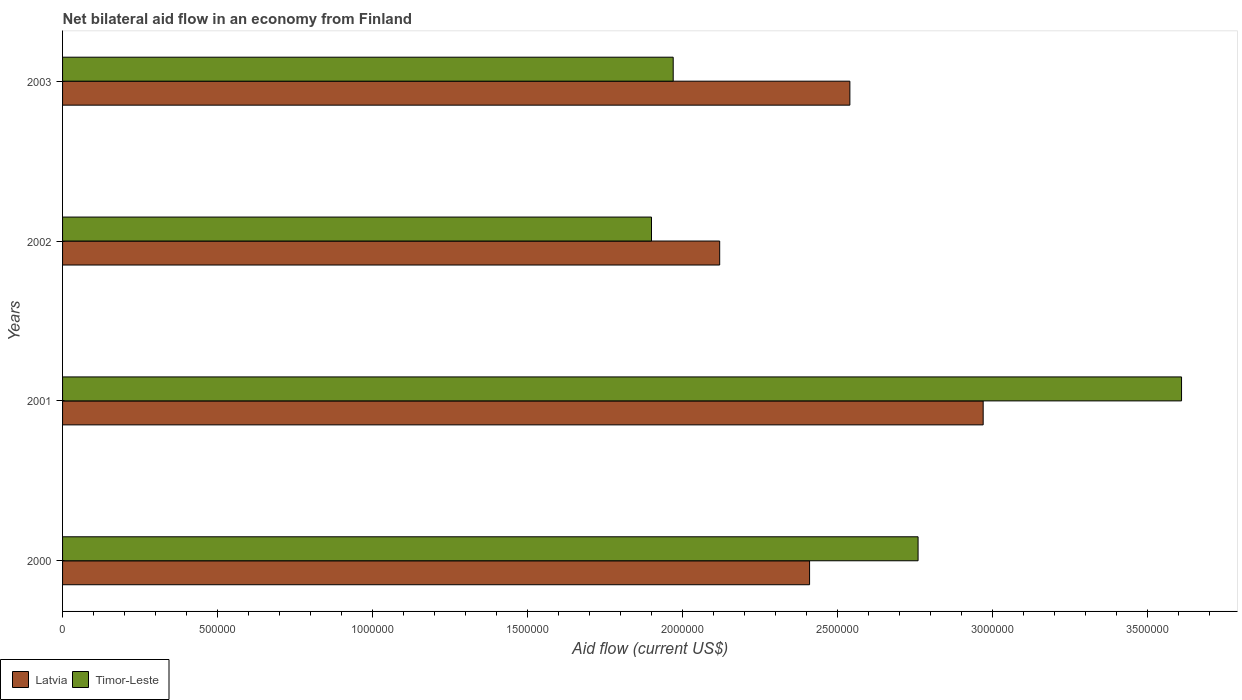How many groups of bars are there?
Ensure brevity in your answer.  4. Are the number of bars per tick equal to the number of legend labels?
Offer a terse response. Yes. What is the label of the 4th group of bars from the top?
Make the answer very short. 2000. What is the net bilateral aid flow in Latvia in 2000?
Your response must be concise. 2.41e+06. Across all years, what is the maximum net bilateral aid flow in Latvia?
Offer a terse response. 2.97e+06. Across all years, what is the minimum net bilateral aid flow in Latvia?
Offer a very short reply. 2.12e+06. In which year was the net bilateral aid flow in Timor-Leste maximum?
Make the answer very short. 2001. What is the total net bilateral aid flow in Latvia in the graph?
Ensure brevity in your answer.  1.00e+07. What is the difference between the net bilateral aid flow in Timor-Leste in 2000 and the net bilateral aid flow in Latvia in 2002?
Offer a terse response. 6.40e+05. What is the average net bilateral aid flow in Latvia per year?
Provide a succinct answer. 2.51e+06. In the year 2002, what is the difference between the net bilateral aid flow in Latvia and net bilateral aid flow in Timor-Leste?
Offer a very short reply. 2.20e+05. What is the ratio of the net bilateral aid flow in Latvia in 2000 to that in 2002?
Give a very brief answer. 1.14. What is the difference between the highest and the second highest net bilateral aid flow in Latvia?
Give a very brief answer. 4.30e+05. What is the difference between the highest and the lowest net bilateral aid flow in Latvia?
Give a very brief answer. 8.50e+05. What does the 1st bar from the top in 2000 represents?
Keep it short and to the point. Timor-Leste. What does the 1st bar from the bottom in 2002 represents?
Your answer should be compact. Latvia. How many bars are there?
Keep it short and to the point. 8. Are all the bars in the graph horizontal?
Offer a very short reply. Yes. How many years are there in the graph?
Your answer should be very brief. 4. What is the difference between two consecutive major ticks on the X-axis?
Provide a succinct answer. 5.00e+05. Where does the legend appear in the graph?
Give a very brief answer. Bottom left. How many legend labels are there?
Make the answer very short. 2. How are the legend labels stacked?
Ensure brevity in your answer.  Horizontal. What is the title of the graph?
Provide a short and direct response. Net bilateral aid flow in an economy from Finland. Does "Spain" appear as one of the legend labels in the graph?
Provide a short and direct response. No. What is the Aid flow (current US$) in Latvia in 2000?
Ensure brevity in your answer.  2.41e+06. What is the Aid flow (current US$) in Timor-Leste in 2000?
Keep it short and to the point. 2.76e+06. What is the Aid flow (current US$) of Latvia in 2001?
Offer a terse response. 2.97e+06. What is the Aid flow (current US$) of Timor-Leste in 2001?
Keep it short and to the point. 3.61e+06. What is the Aid flow (current US$) in Latvia in 2002?
Offer a terse response. 2.12e+06. What is the Aid flow (current US$) of Timor-Leste in 2002?
Ensure brevity in your answer.  1.90e+06. What is the Aid flow (current US$) of Latvia in 2003?
Your answer should be very brief. 2.54e+06. What is the Aid flow (current US$) in Timor-Leste in 2003?
Ensure brevity in your answer.  1.97e+06. Across all years, what is the maximum Aid flow (current US$) of Latvia?
Offer a terse response. 2.97e+06. Across all years, what is the maximum Aid flow (current US$) in Timor-Leste?
Offer a terse response. 3.61e+06. Across all years, what is the minimum Aid flow (current US$) in Latvia?
Provide a short and direct response. 2.12e+06. Across all years, what is the minimum Aid flow (current US$) in Timor-Leste?
Keep it short and to the point. 1.90e+06. What is the total Aid flow (current US$) in Latvia in the graph?
Your answer should be very brief. 1.00e+07. What is the total Aid flow (current US$) in Timor-Leste in the graph?
Your response must be concise. 1.02e+07. What is the difference between the Aid flow (current US$) of Latvia in 2000 and that in 2001?
Ensure brevity in your answer.  -5.60e+05. What is the difference between the Aid flow (current US$) in Timor-Leste in 2000 and that in 2001?
Provide a short and direct response. -8.50e+05. What is the difference between the Aid flow (current US$) in Latvia in 2000 and that in 2002?
Your response must be concise. 2.90e+05. What is the difference between the Aid flow (current US$) of Timor-Leste in 2000 and that in 2002?
Provide a short and direct response. 8.60e+05. What is the difference between the Aid flow (current US$) in Timor-Leste in 2000 and that in 2003?
Provide a succinct answer. 7.90e+05. What is the difference between the Aid flow (current US$) of Latvia in 2001 and that in 2002?
Offer a terse response. 8.50e+05. What is the difference between the Aid flow (current US$) in Timor-Leste in 2001 and that in 2002?
Your response must be concise. 1.71e+06. What is the difference between the Aid flow (current US$) of Timor-Leste in 2001 and that in 2003?
Keep it short and to the point. 1.64e+06. What is the difference between the Aid flow (current US$) in Latvia in 2002 and that in 2003?
Offer a terse response. -4.20e+05. What is the difference between the Aid flow (current US$) in Latvia in 2000 and the Aid flow (current US$) in Timor-Leste in 2001?
Make the answer very short. -1.20e+06. What is the difference between the Aid flow (current US$) in Latvia in 2000 and the Aid flow (current US$) in Timor-Leste in 2002?
Your response must be concise. 5.10e+05. What is the difference between the Aid flow (current US$) in Latvia in 2001 and the Aid flow (current US$) in Timor-Leste in 2002?
Make the answer very short. 1.07e+06. What is the average Aid flow (current US$) of Latvia per year?
Make the answer very short. 2.51e+06. What is the average Aid flow (current US$) in Timor-Leste per year?
Keep it short and to the point. 2.56e+06. In the year 2000, what is the difference between the Aid flow (current US$) in Latvia and Aid flow (current US$) in Timor-Leste?
Give a very brief answer. -3.50e+05. In the year 2001, what is the difference between the Aid flow (current US$) in Latvia and Aid flow (current US$) in Timor-Leste?
Your answer should be very brief. -6.40e+05. In the year 2002, what is the difference between the Aid flow (current US$) of Latvia and Aid flow (current US$) of Timor-Leste?
Offer a terse response. 2.20e+05. In the year 2003, what is the difference between the Aid flow (current US$) in Latvia and Aid flow (current US$) in Timor-Leste?
Make the answer very short. 5.70e+05. What is the ratio of the Aid flow (current US$) of Latvia in 2000 to that in 2001?
Offer a terse response. 0.81. What is the ratio of the Aid flow (current US$) in Timor-Leste in 2000 to that in 2001?
Offer a very short reply. 0.76. What is the ratio of the Aid flow (current US$) of Latvia in 2000 to that in 2002?
Provide a short and direct response. 1.14. What is the ratio of the Aid flow (current US$) in Timor-Leste in 2000 to that in 2002?
Your response must be concise. 1.45. What is the ratio of the Aid flow (current US$) of Latvia in 2000 to that in 2003?
Make the answer very short. 0.95. What is the ratio of the Aid flow (current US$) in Timor-Leste in 2000 to that in 2003?
Your answer should be very brief. 1.4. What is the ratio of the Aid flow (current US$) in Latvia in 2001 to that in 2002?
Provide a short and direct response. 1.4. What is the ratio of the Aid flow (current US$) of Latvia in 2001 to that in 2003?
Make the answer very short. 1.17. What is the ratio of the Aid flow (current US$) of Timor-Leste in 2001 to that in 2003?
Your answer should be very brief. 1.83. What is the ratio of the Aid flow (current US$) of Latvia in 2002 to that in 2003?
Your response must be concise. 0.83. What is the ratio of the Aid flow (current US$) in Timor-Leste in 2002 to that in 2003?
Offer a terse response. 0.96. What is the difference between the highest and the second highest Aid flow (current US$) of Latvia?
Give a very brief answer. 4.30e+05. What is the difference between the highest and the second highest Aid flow (current US$) in Timor-Leste?
Offer a terse response. 8.50e+05. What is the difference between the highest and the lowest Aid flow (current US$) of Latvia?
Give a very brief answer. 8.50e+05. What is the difference between the highest and the lowest Aid flow (current US$) of Timor-Leste?
Provide a succinct answer. 1.71e+06. 